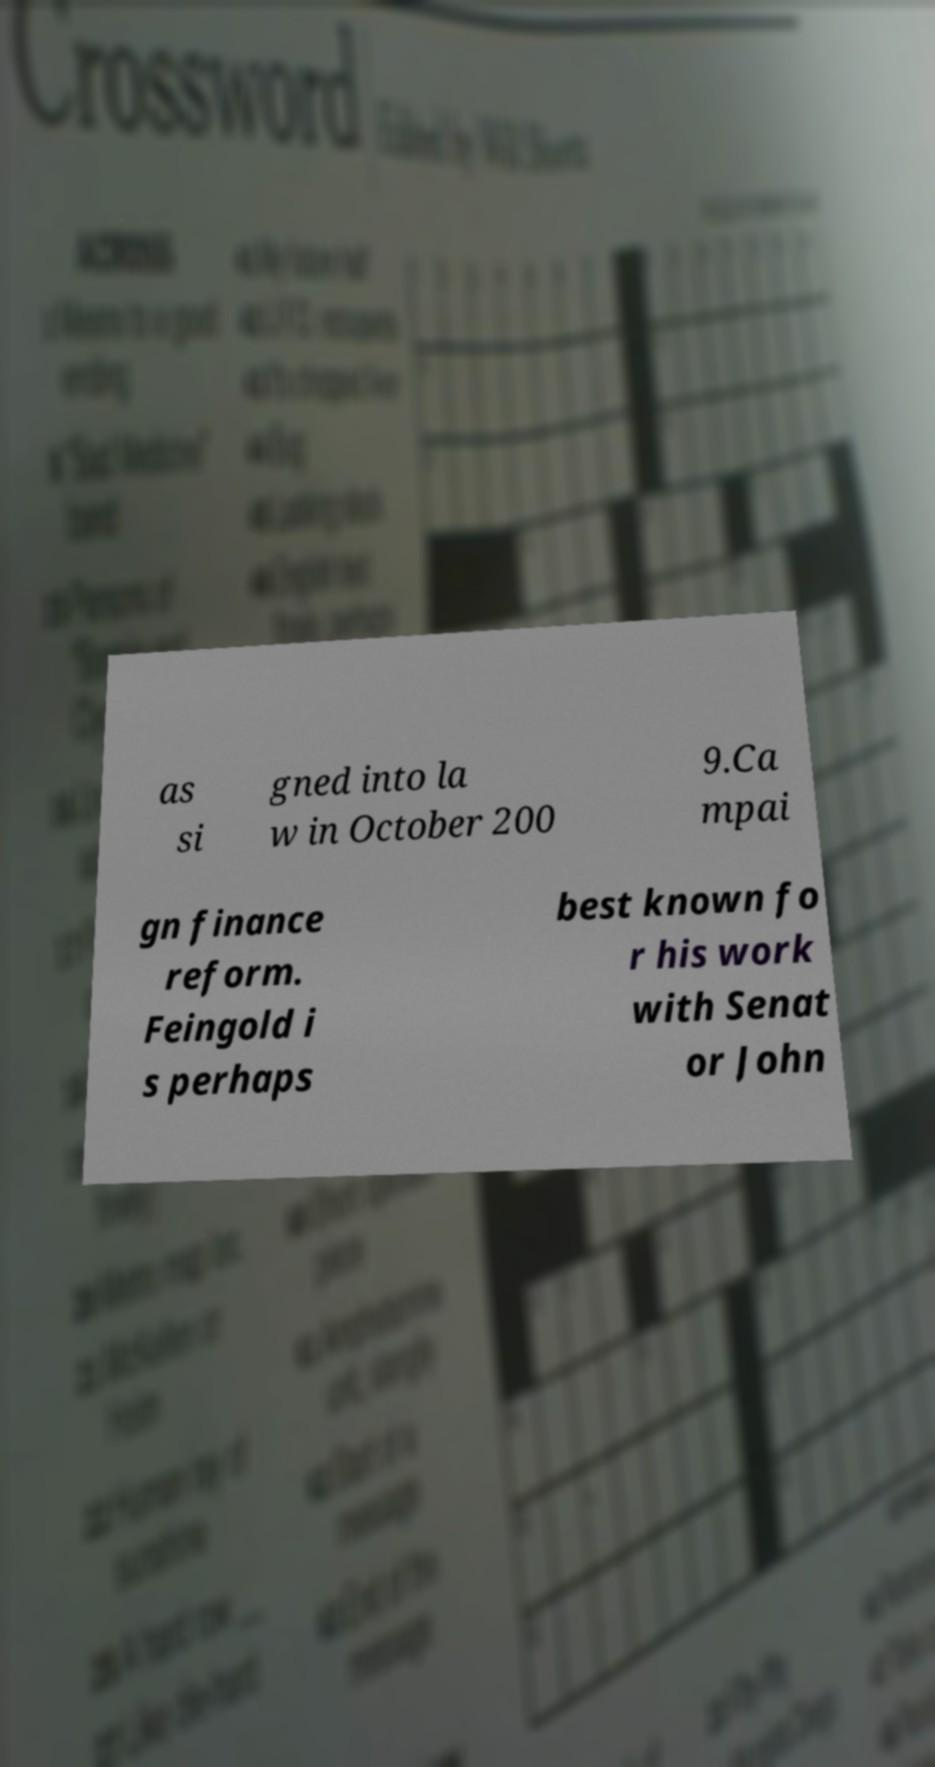Could you extract and type out the text from this image? as si gned into la w in October 200 9.Ca mpai gn finance reform. Feingold i s perhaps best known fo r his work with Senat or John 